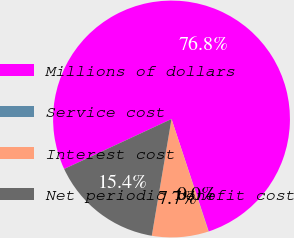Convert chart. <chart><loc_0><loc_0><loc_500><loc_500><pie_chart><fcel>Millions of dollars<fcel>Service cost<fcel>Interest cost<fcel>Net periodic benefit cost<nl><fcel>76.84%<fcel>0.04%<fcel>7.72%<fcel>15.4%<nl></chart> 